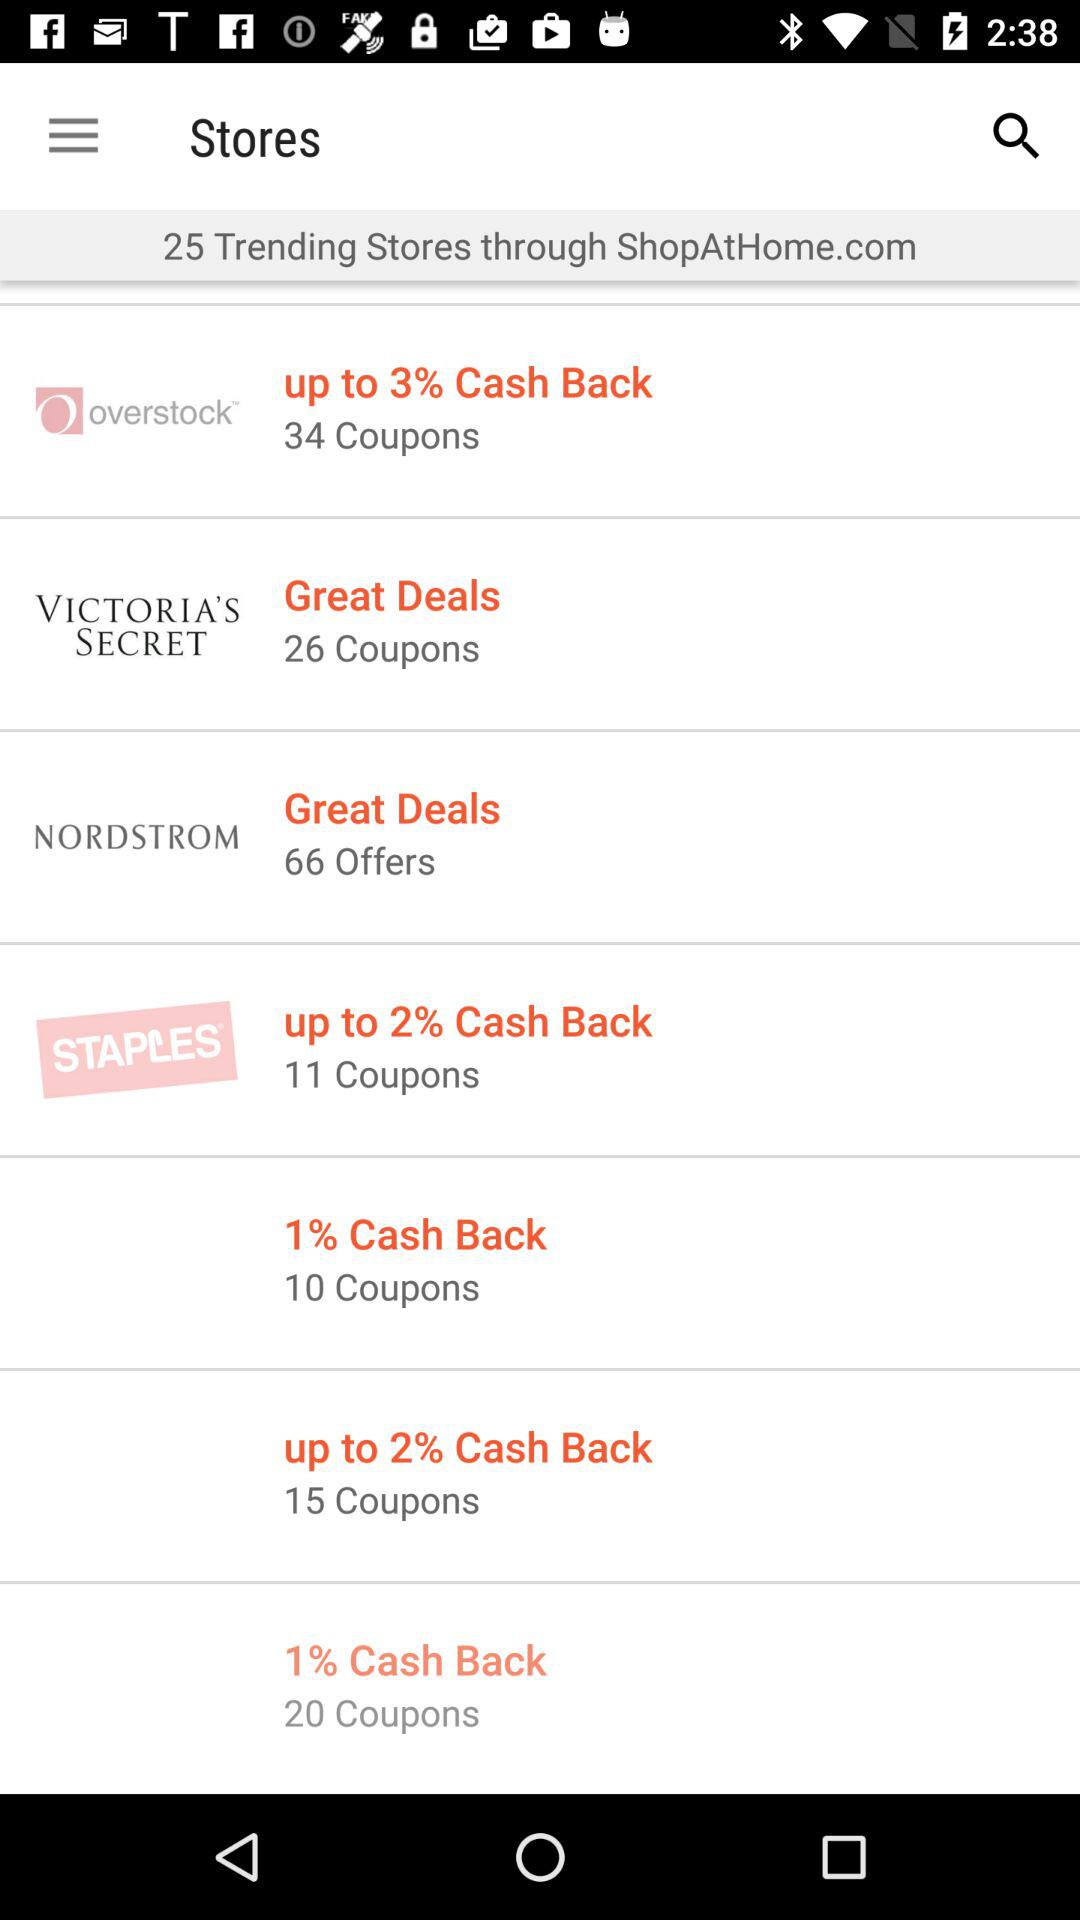What is the total count of stores? The total count of stores is 25. 